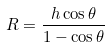Convert formula to latex. <formula><loc_0><loc_0><loc_500><loc_500>R = \frac { h \cos \theta } { 1 - \cos \theta }</formula> 